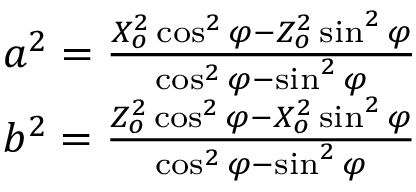Convert formula to latex. <formula><loc_0><loc_0><loc_500><loc_500>\begin{array} { r l } & { a ^ { 2 } = \frac { X _ { o } ^ { 2 } \cos ^ { 2 } \varphi - Z _ { o } ^ { 2 } \sin ^ { 2 } \varphi } { \cos ^ { 2 } \varphi - \sin ^ { 2 } \varphi } } \\ & { b ^ { 2 } = \frac { Z _ { o } ^ { 2 } \cos ^ { 2 } \varphi - X _ { o } ^ { 2 } \sin ^ { 2 } \varphi } { \cos ^ { 2 } \varphi - \sin ^ { 2 } \varphi } } \end{array}</formula> 